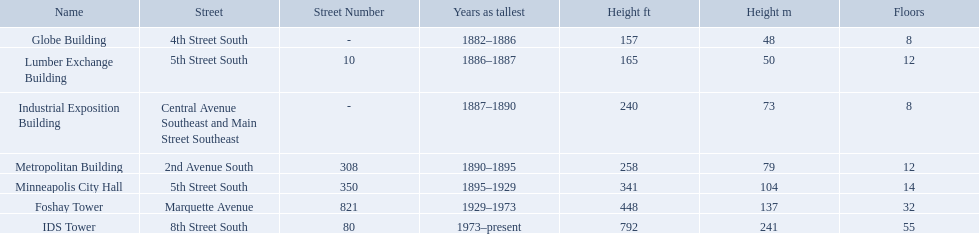What years was 240 ft considered tall? 1887–1890. What building held this record? Industrial Exposition Building. What are all the building names? Globe Building, Lumber Exchange Building, Industrial Exposition Building, Metropolitan Building, Minneapolis City Hall, Foshay Tower, IDS Tower. And their heights? 157 (48), 165 (50), 240 (73), 258 (79), 341 (104), 448 (137), 792 (241). Between metropolitan building and lumber exchange building, which is taller? Metropolitan Building. How many floors does the globe building have? 8. Which building has 14 floors? Minneapolis City Hall. The lumber exchange building has the same number of floors as which building? Metropolitan Building. 